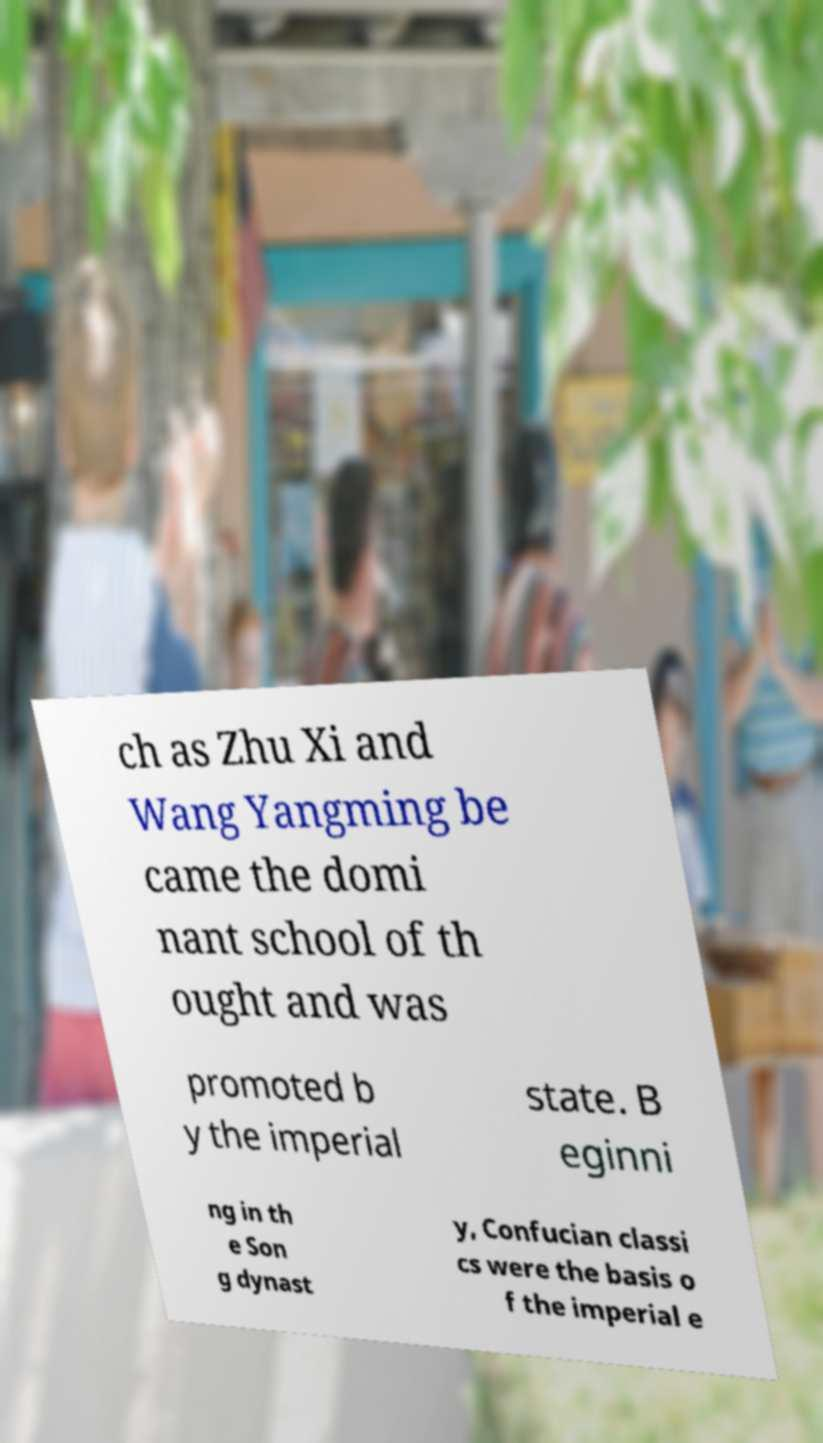For documentation purposes, I need the text within this image transcribed. Could you provide that? ch as Zhu Xi and Wang Yangming be came the domi nant school of th ought and was promoted b y the imperial state. B eginni ng in th e Son g dynast y, Confucian classi cs were the basis o f the imperial e 